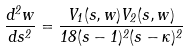Convert formula to latex. <formula><loc_0><loc_0><loc_500><loc_500>\frac { d ^ { 2 } w } { d s ^ { 2 } } = \frac { V _ { 1 } ( s , w ) V _ { 2 } ( s , w ) } { 1 8 ( s - 1 ) ^ { 2 } ( s - \kappa ) ^ { 2 } }</formula> 